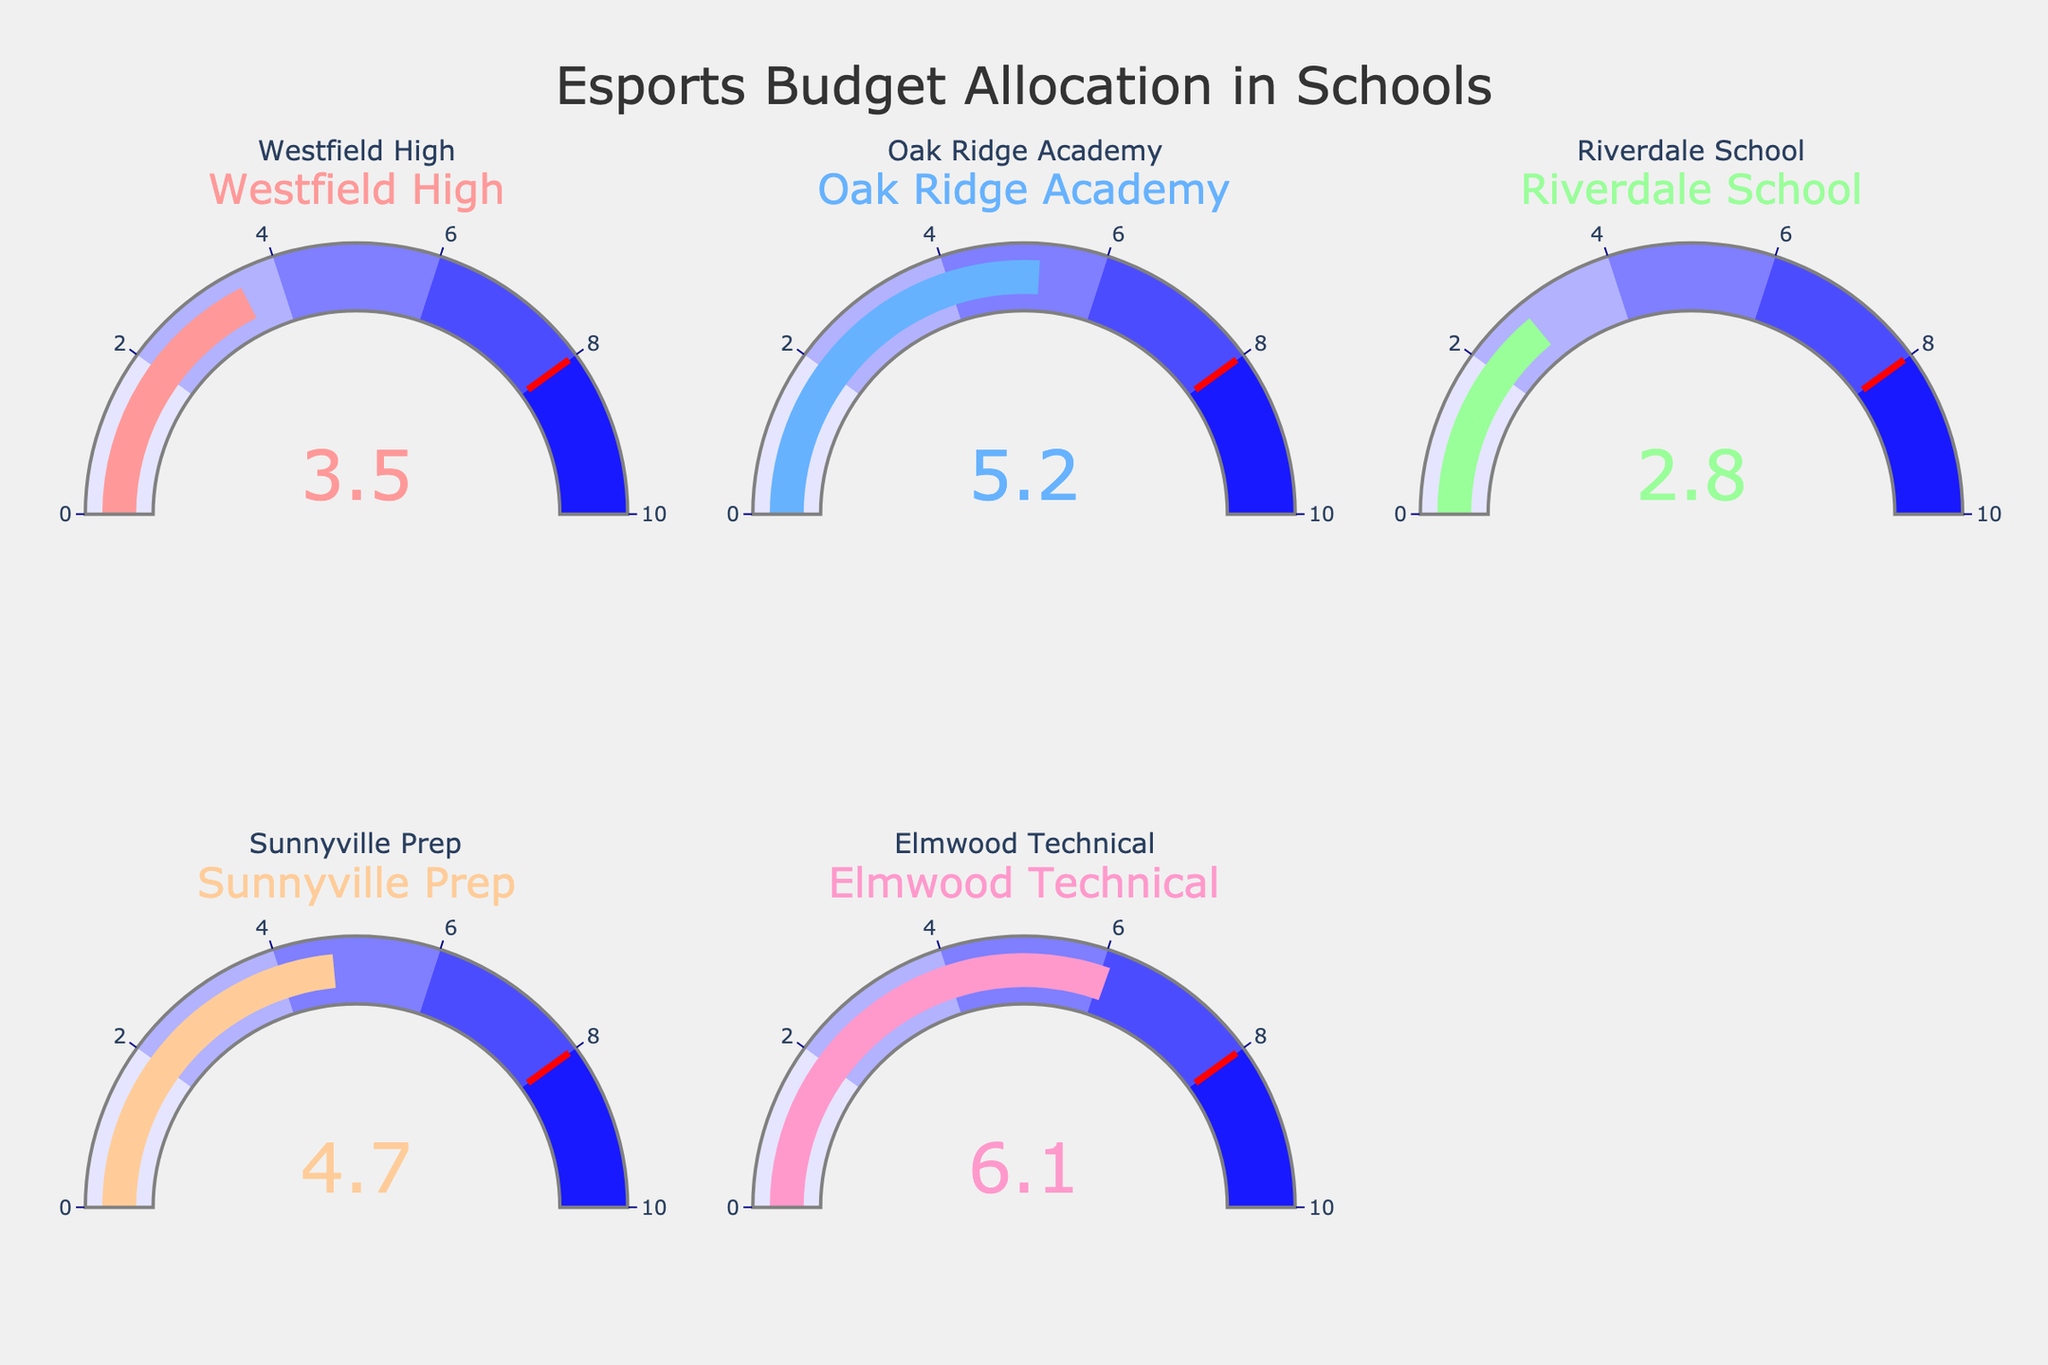How much of the athletic budget does Sunnyville Prep allocate to esports? According to the gauge chart for Sunnyville Prep, it allocates 4.7% of its athletic budget to esports.
Answer: 4.7% Which school allocates the highest percentage of its athletic budget to esports? By comparing the values of all the gauges, Elmwood Technical allocates the highest percentage, which is 6.1%.
Answer: Elmwood Technical What is the total percentage of the athletic budget allocated to esports by all the schools combined? Add the percentages of each school: 3.5 + 5.2 + 2.8 + 4.7 + 6.1 = 22.3%. Therefore, the total allocation is 22.3%.
Answer: 22.3% Which school allocates less than 4% of its athletic budget to esports? By checking each gauge, Westfield High (3.5%) and Riverdale School (2.8%) allocate less than 4% to esports.
Answer: Westfield High, Riverdale School How much more of the athletic budget does Elmwood Technical allocate to esports compared to Riverdale School? Elmwood allocates 6.1%, and Riverdale allocates 2.8%, so the difference is 6.1 - 2.8 = 3.3%.
Answer: 3.3% What's the median percentage of esports budget allocation across all the schools? The percentages in sorted order are 2.8, 3.5, 4.7, 5.2, and 6.1. The median value is the middle one, which is 4.7.
Answer: 4.7 Are there any schools that allocate exactly 5% of their athletic budget to esports? By examining the gauge chart values, no school allocates exactly 5% to esports.
Answer: No Which school allocates the closest to 4% of its athletic budget to esports? By reviewing the values, Westfield High allocates 3.5%, and Sunnyville Prep allocates 4.7%. Since 3.5 is closer to 4 than 4.7 is, Westfield High is the closest.
Answer: Westfield High What is the average percentage of the athletic budget allocated to esports across all schools? Sum up all the percentages: 3.5 + 5.2 + 2.8 + 4.7 + 6.1 = 22.3. Divide by the number of schools (5), so the average is 22.3 / 5 = 4.46%.
Answer: 4.46 